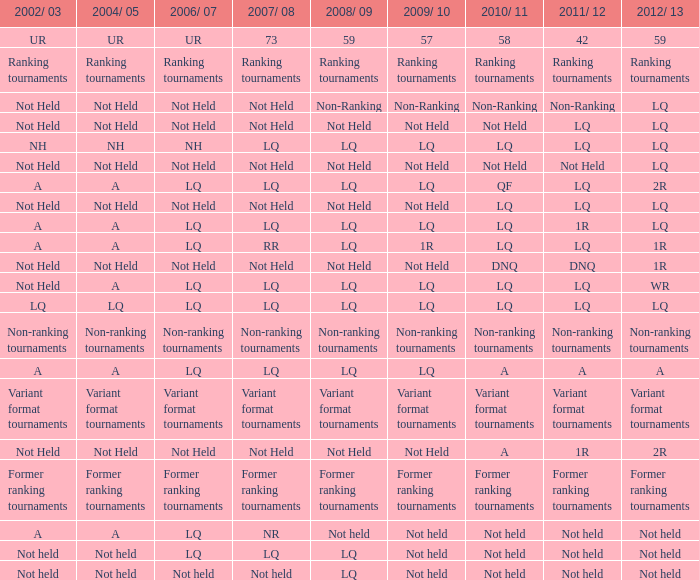Identify the 2009/10 and 2011/12 occurrences of lq, as well as the 2008/09 event that did not take place. Not Held, Not Held. 